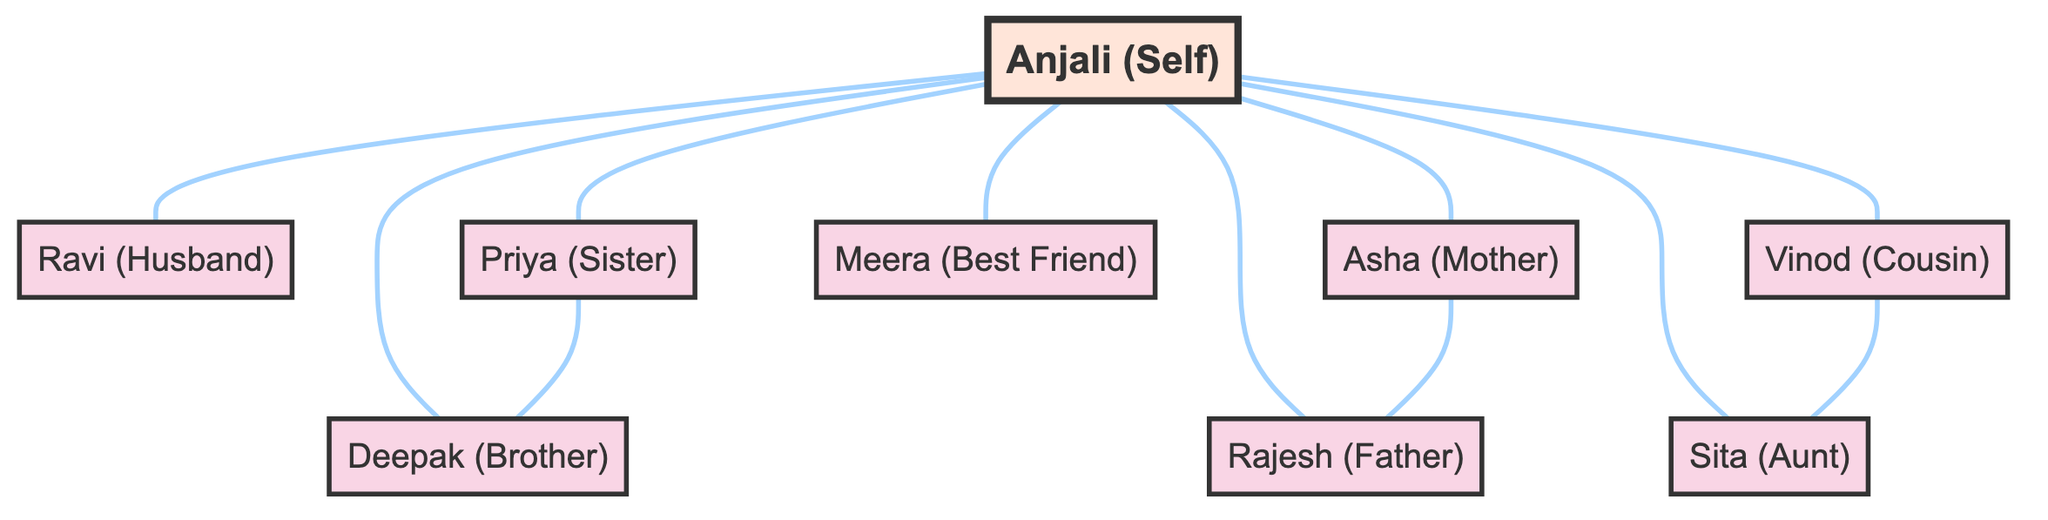What is the total number of nodes in the diagram? The diagram includes all individuals represented in the data, which totals to 9 nodes (Anjali, Ravi, Priya, Deepak, Asha, Rajesh, Meera, Vinod, and Sita).
Answer: 9 Who is connected to Anjali? Anjali (Self) is connected to Ravi (Husband), Priya (Sister), Deepak (Brother), Asha (Mother), Rajesh (Father), Meera (Best Friend), Vinod (Cousin), and Sita (Aunt); therefore, the individuals connected to her are these 8 people.
Answer: 8 How many siblings does Anjali have? Anjali has two siblings: Priya (Sister) and Deepak (Brother), as indicated by the direct connections from Anjali to both individuals in the diagram.
Answer: 2 What relationship does Asha have with Anjali? Asha is labeled as the Mother of Anjali, which is stated directly in the relationship type for Asha in the diagram.
Answer: Mother Which two individuals are siblings in the diagram? The diagram shows that Priya and Deepak are siblings as there is a direct connection between them, indicating a sibling relationship.
Answer: Priya and Deepak Who is Anjali's best friend? Anjali's best friend is Meera, as shown in the diagram with a direct connection labeled "Best Friend" between Anjali and Meera.
Answer: Meera How many edges are connected to Anjali? Anjali has 8 edges connecting her to Ravi, Priya, Deepak, Asha, Rajesh, Meera, Vinod, and Sita, which represents each relationship she has with these individuals.
Answer: 8 What type of diagram is represented? The diagram is a Network Diagram, which illustrates social connections and support networks among family and friends, as indicated by the relationships described.
Answer: Network Diagram Who are the parents of Anjali? The two individuals connected to Anjali as her parents are Asha (Mother) and Rajesh (Father), which can be identified through the connection lines in the diagram.
Answer: Asha and Rajesh 